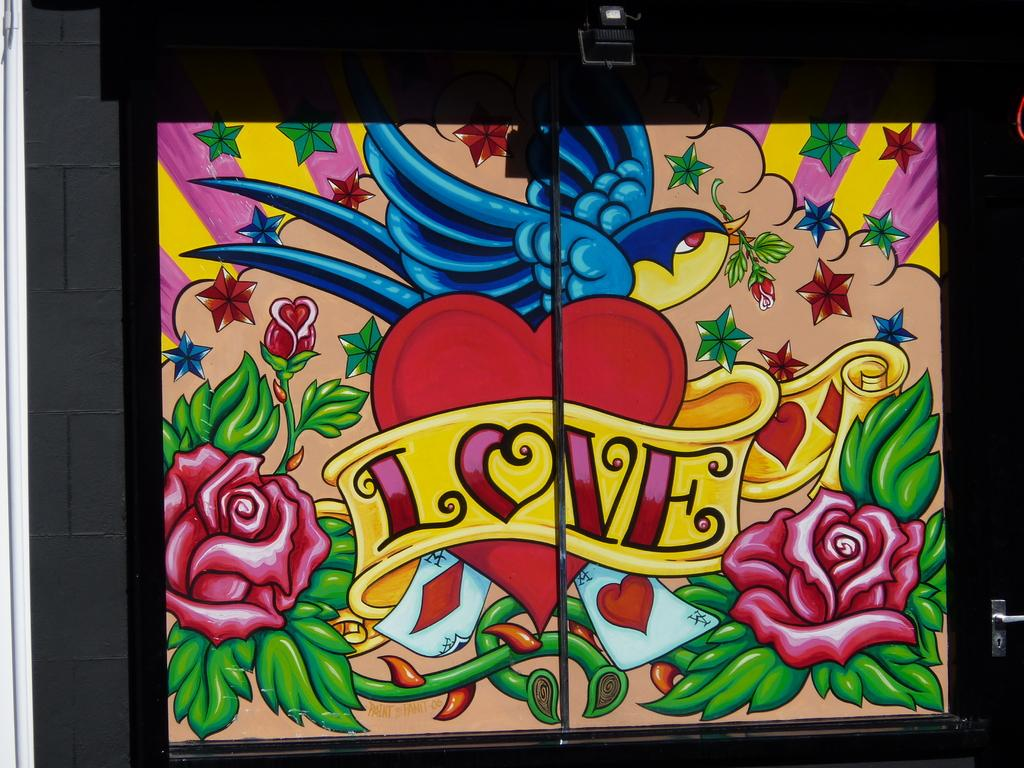What object can be used to open or close a door in the image? There is a door handle in the image. What type of artwork is present in the image? There is a painting on a black surface in the image. What aspect of the image seems to be emphasized? The image appears to have a focus on light. What type of structure is being lifted in the image? There is no structure being lifted in the image; it only features a door handle and a painting on a black surface. 